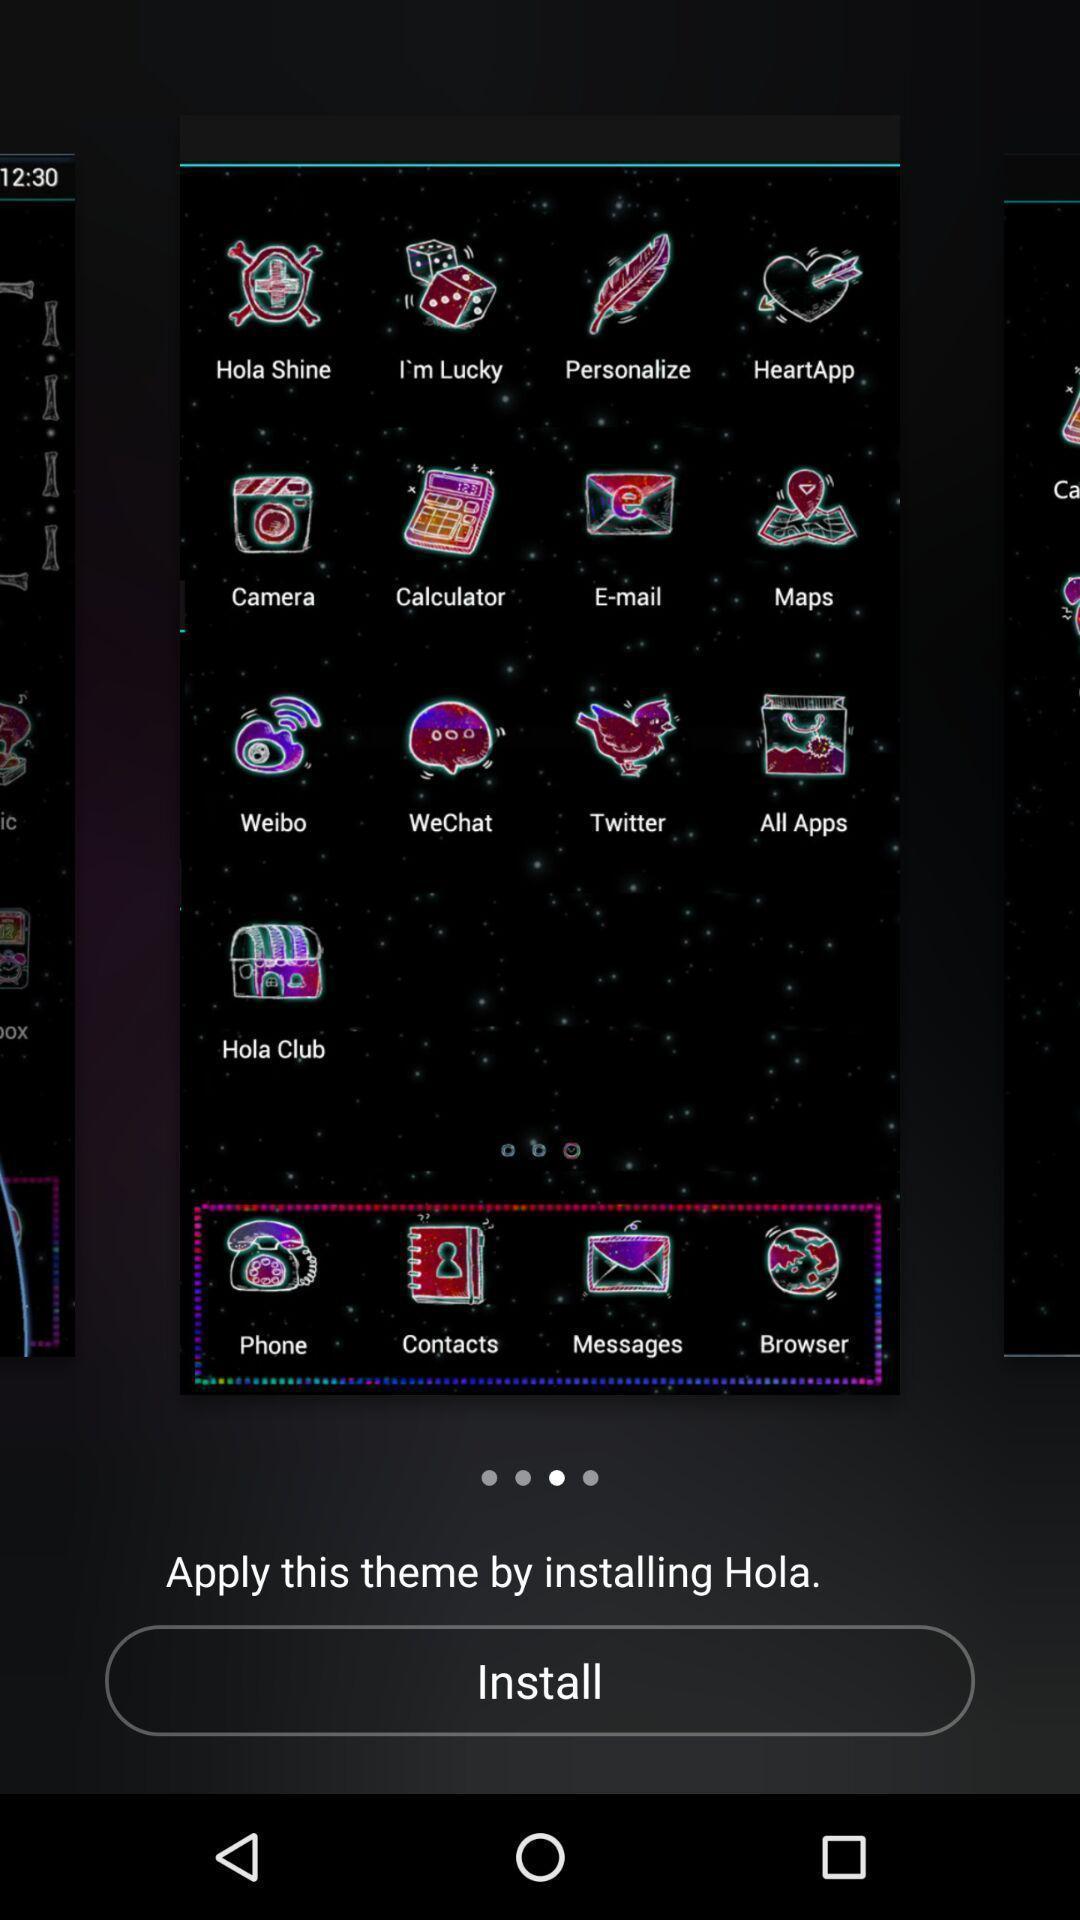Describe the key features of this screenshot. Screen displaying different theme apps. 